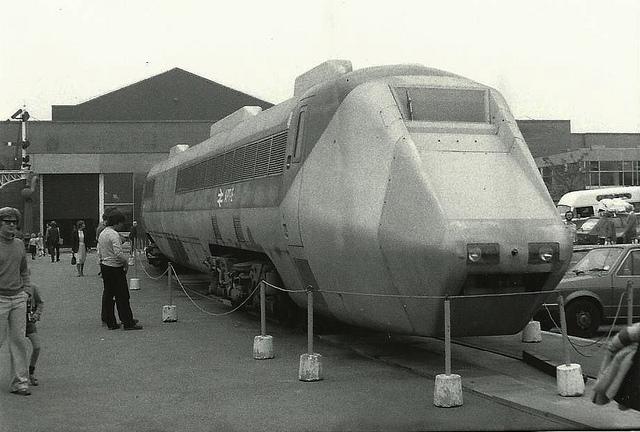Is this a transportation vehicle?
Quick response, please. Yes. Is this photo in color?
Answer briefly. No. Is this photo recent?
Short answer required. No. 